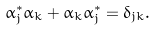Convert formula to latex. <formula><loc_0><loc_0><loc_500><loc_500>\alpha _ { j } ^ { \ast } \alpha _ { k } + \alpha _ { k } \alpha _ { j } ^ { \ast } = \delta _ { j k } .</formula> 